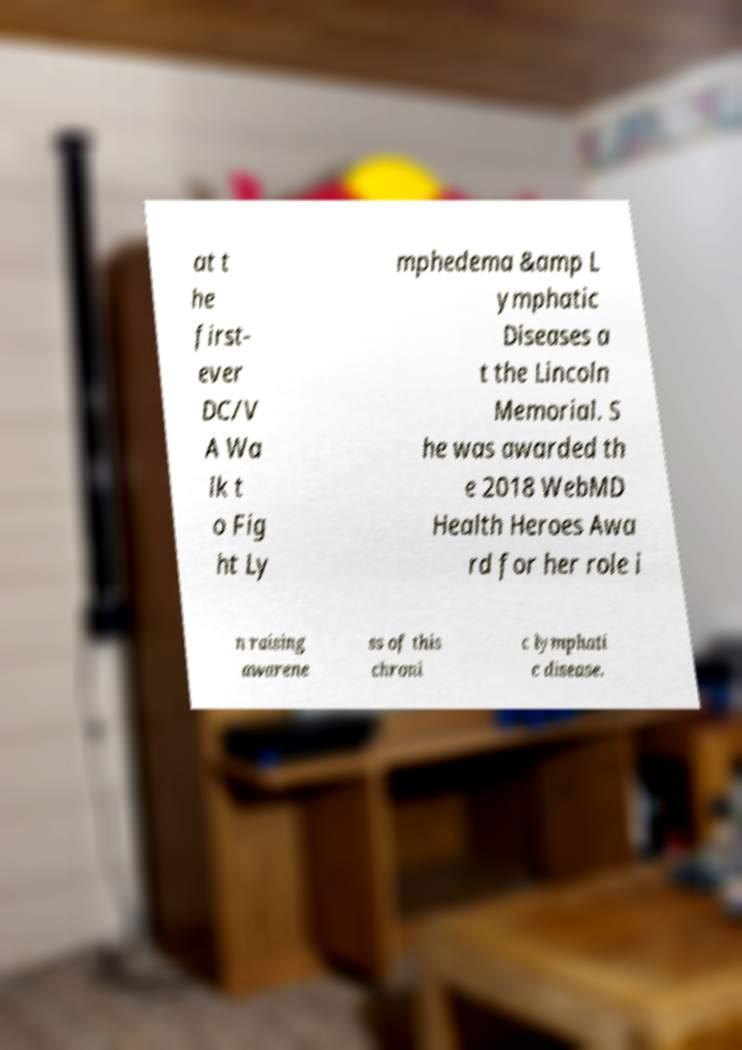Can you accurately transcribe the text from the provided image for me? at t he first- ever DC/V A Wa lk t o Fig ht Ly mphedema &amp L ymphatic Diseases a t the Lincoln Memorial. S he was awarded th e 2018 WebMD Health Heroes Awa rd for her role i n raising awarene ss of this chroni c lymphati c disease. 